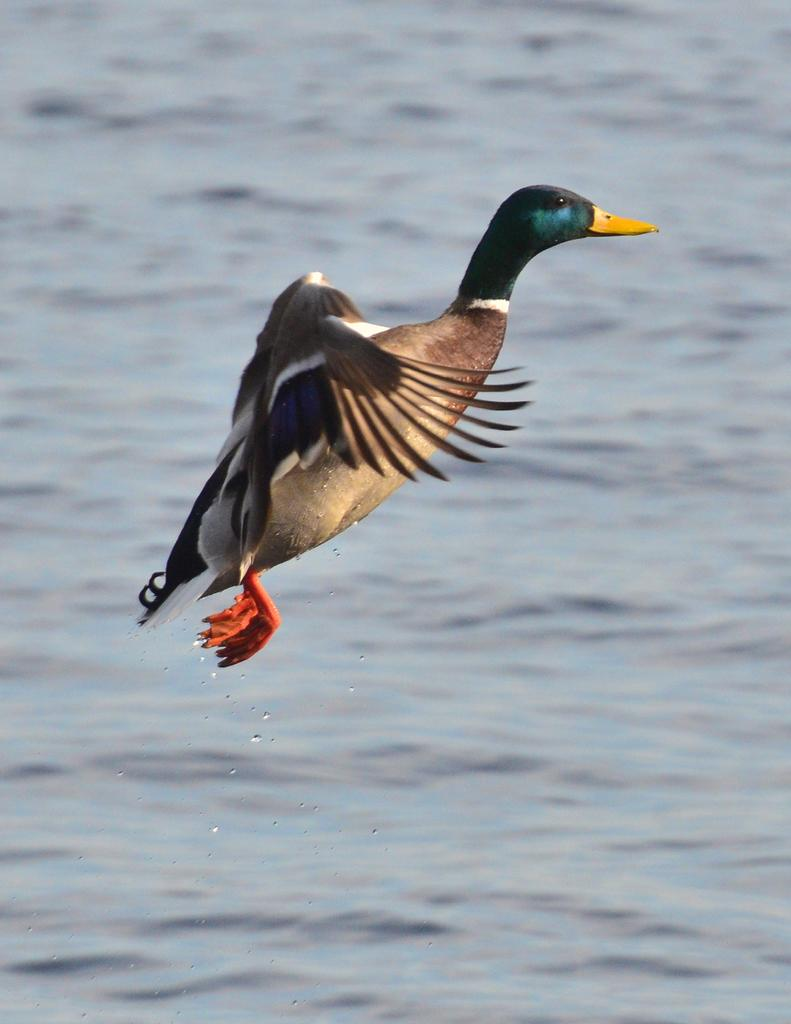What animal is present in the picture? There is a duck in the picture. What is the duck doing in the picture? The duck is flying on the water in the picture. What is the primary color of the duck? The duck has a light brown color. Are there any other colors visible on the duck? Yes, some parts of the duck are green, yellow, and cream in color. What type of heart can be seen beating inside the duck in the image? There is no heart visible inside the duck in the image, as it is a photograph of a duck and not a medical illustration. 